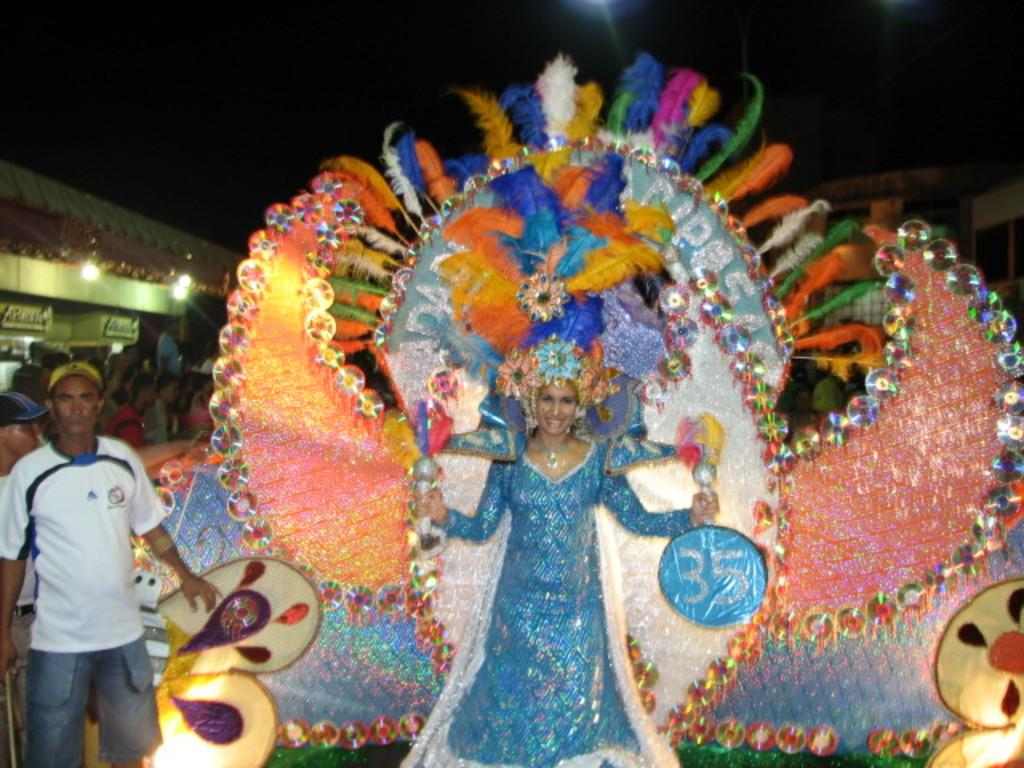What is the main subject of the image? There is a woman standing in the image. Are there any other people in the image besides the woman? Yes, there are people standing in the image. What can be seen in the background or foreground of the image? There are lights visible in the image. What is the price of the crime committed in the image? There is no crime or price mentioned in the image; it simply shows a woman and other people standing with lights visible in the background. 